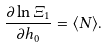<formula> <loc_0><loc_0><loc_500><loc_500>\frac { \partial \ln \Xi _ { 1 } } { \partial h _ { 0 } } = \langle N \rangle .</formula> 